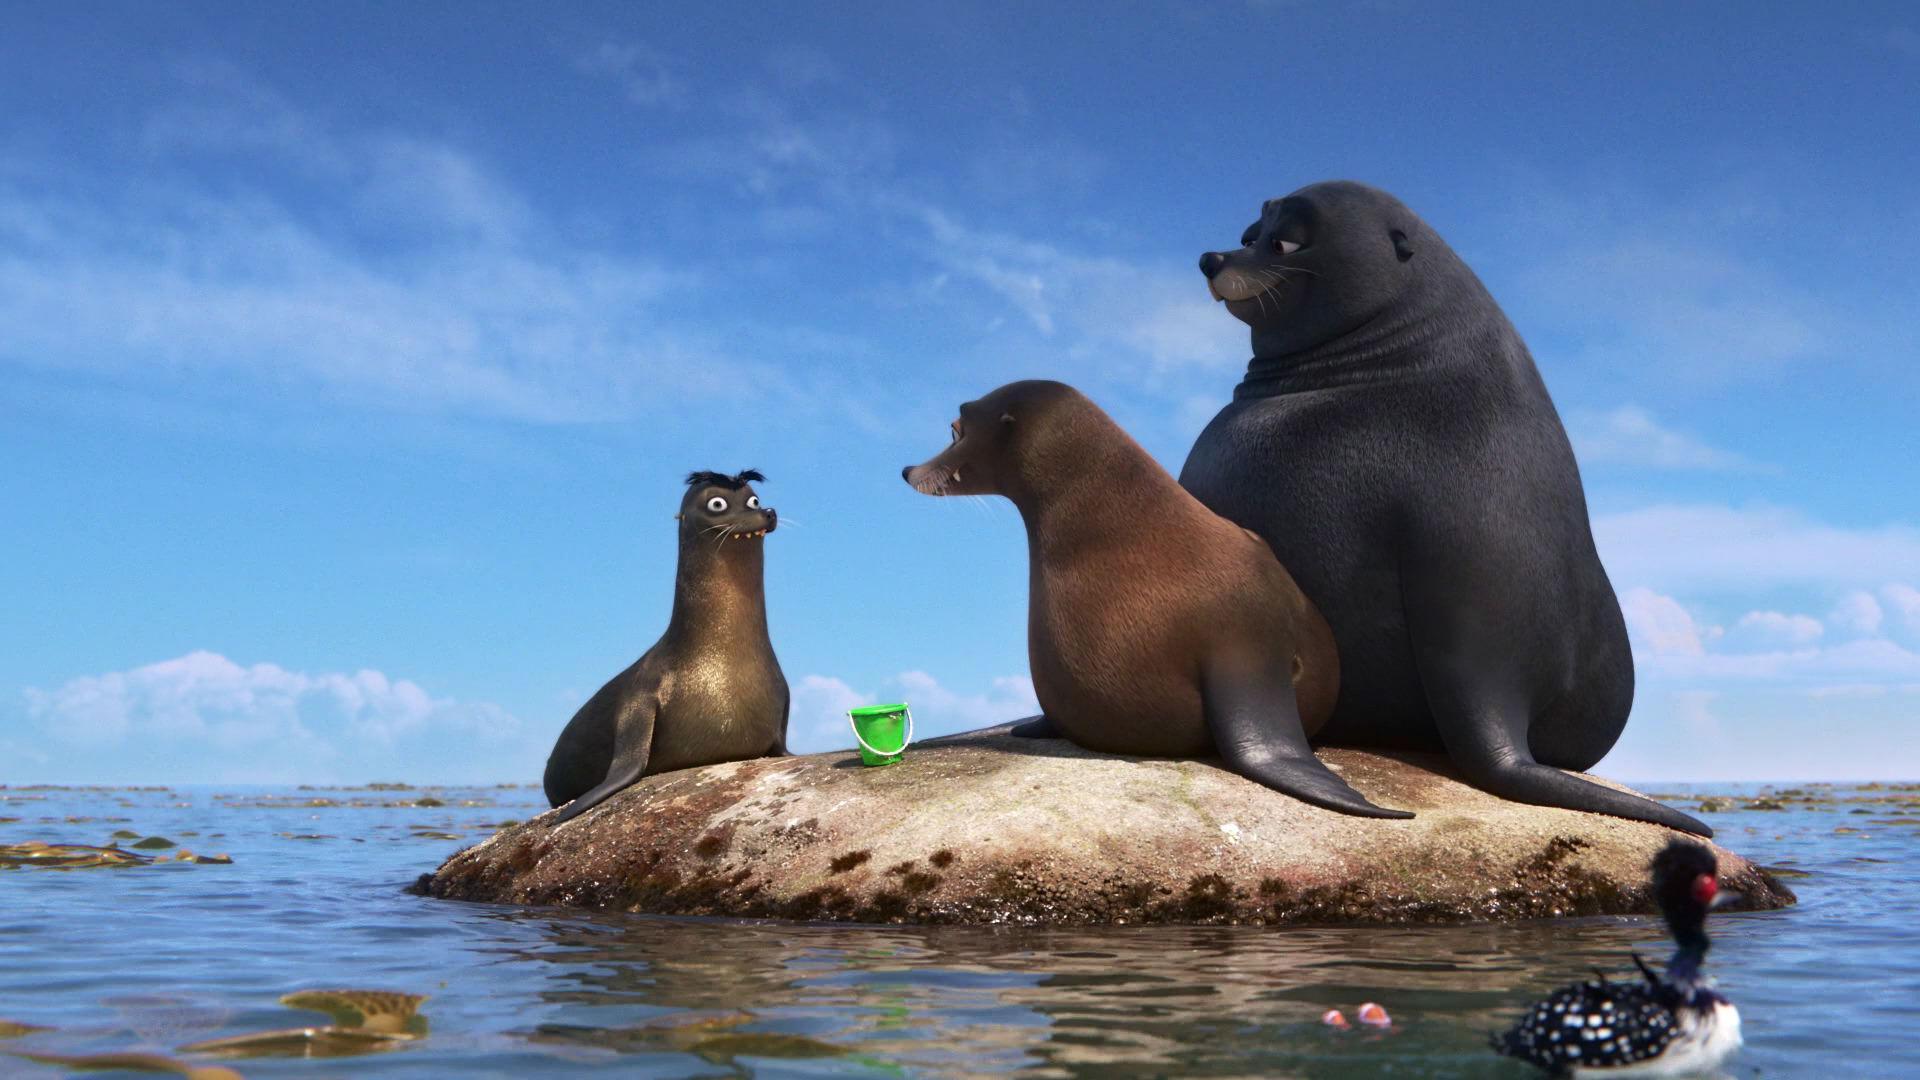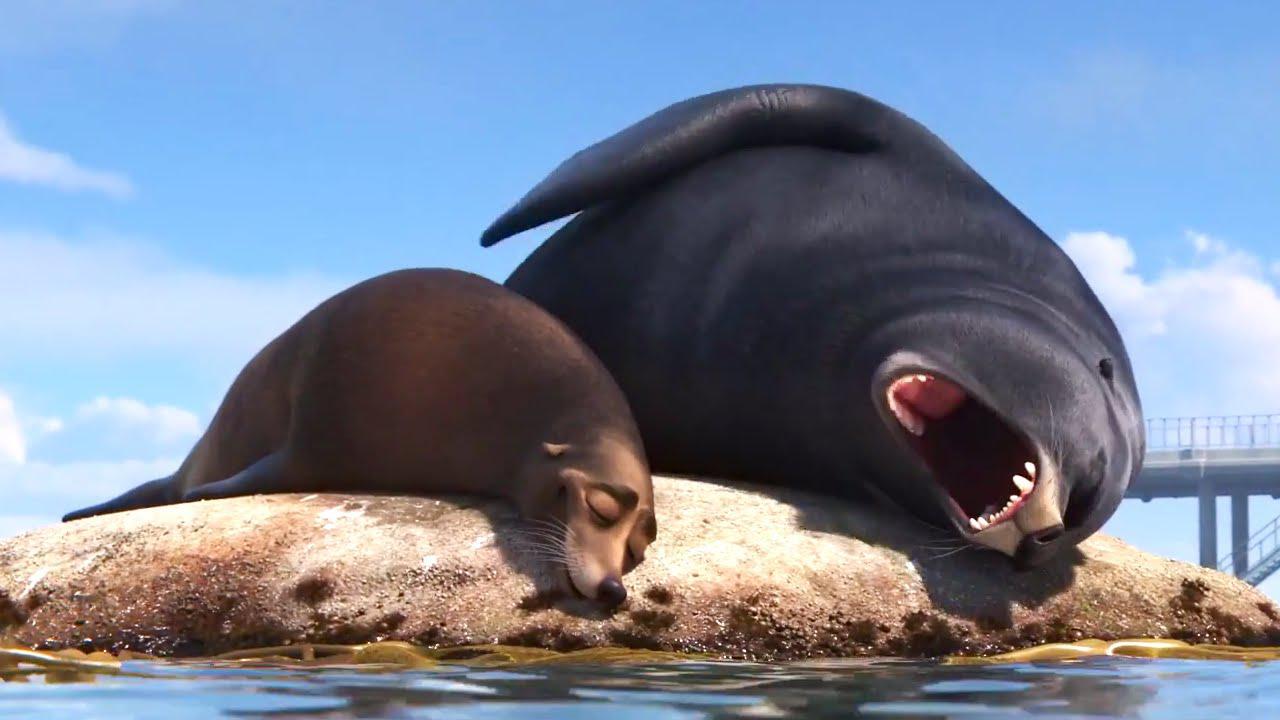The first image is the image on the left, the second image is the image on the right. Evaluate the accuracy of this statement regarding the images: "One image shoes three seals interacting with a small green bucket, and the other image shows two seals on a rock, one black and one brown.". Is it true? Answer yes or no. Yes. The first image is the image on the left, the second image is the image on the right. For the images shown, is this caption "In one image, two seals are alone together on a small mound surrounded by water, and in the other image, a third seal has joined them on the mound." true? Answer yes or no. Yes. 